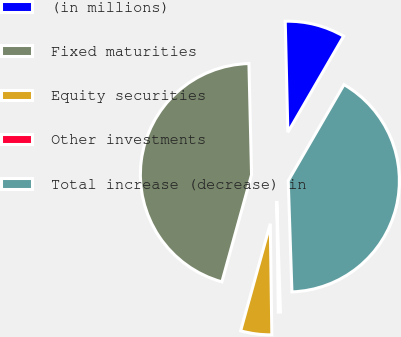<chart> <loc_0><loc_0><loc_500><loc_500><pie_chart><fcel>(in millions)<fcel>Fixed maturities<fcel>Equity securities<fcel>Other investments<fcel>Total increase (decrease) in<nl><fcel>8.74%<fcel>45.32%<fcel>4.52%<fcel>0.31%<fcel>41.1%<nl></chart> 